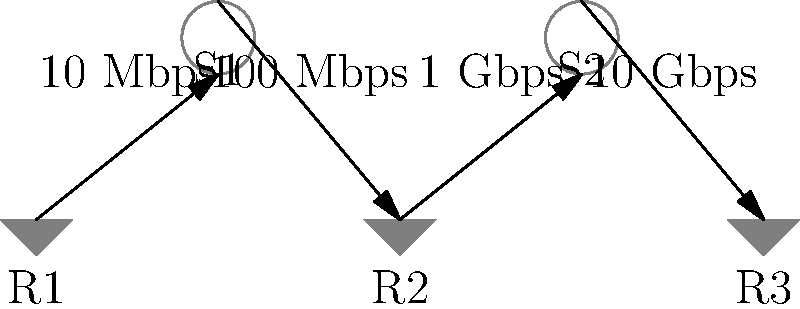In the network topology shown, a 100 MB file needs to be transferred from R1 to R3. Assuming no other traffic and negligible processing time at each node, how long will it take for the file to reach R3? Express your answer in seconds. To solve this problem, we need to follow these steps:

1. Identify the path: The file will travel from R1 → S1 → R2 → S2 → R3.

2. Determine the bottleneck: The slowest link in the path will determine the overall transfer time. Let's convert all speeds to bits per second (bps):
   - R1 to S1: 10 Mbps = $10 \times 10^6$ bps
   - S1 to R2: 100 Mbps = $100 \times 10^6$ bps
   - R2 to S2: 1 Gbps = $1 \times 10^9$ bps
   - S2 to R3: 10 Gbps = $10 \times 10^9$ bps

   The bottleneck is the 10 Mbps link between R1 and S1.

3. Convert file size to bits:
   100 MB = 100 * 8 Mb = 800 Mb = $800 \times 10^6$ bits

4. Calculate transfer time:
   Time = File size / Transfer rate
   = $800 \times 10^6$ bits / ($10 \times 10^6$ bps)
   = 80 seconds

Therefore, it will take 80 seconds for the file to reach R3.
Answer: 80 seconds 